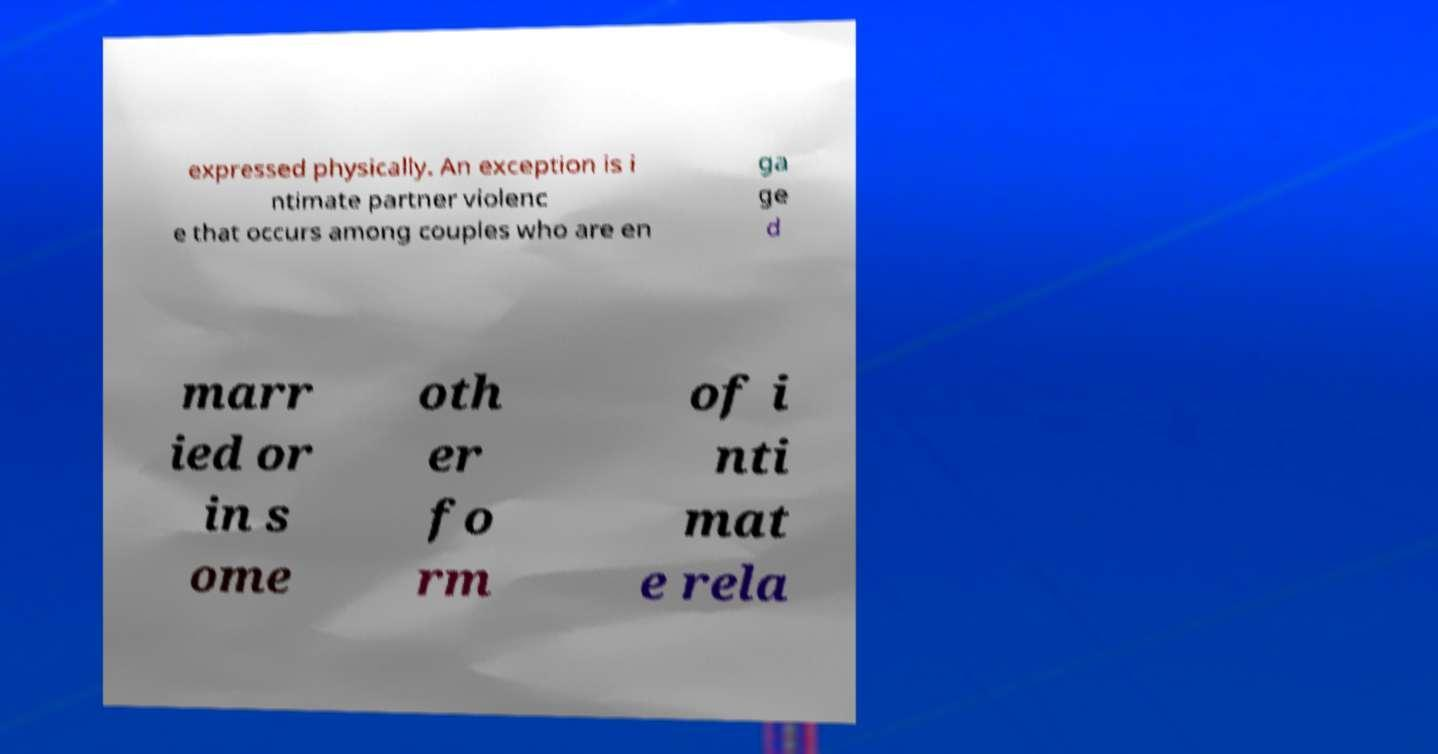There's text embedded in this image that I need extracted. Can you transcribe it verbatim? expressed physically. An exception is i ntimate partner violenc e that occurs among couples who are en ga ge d marr ied or in s ome oth er fo rm of i nti mat e rela 